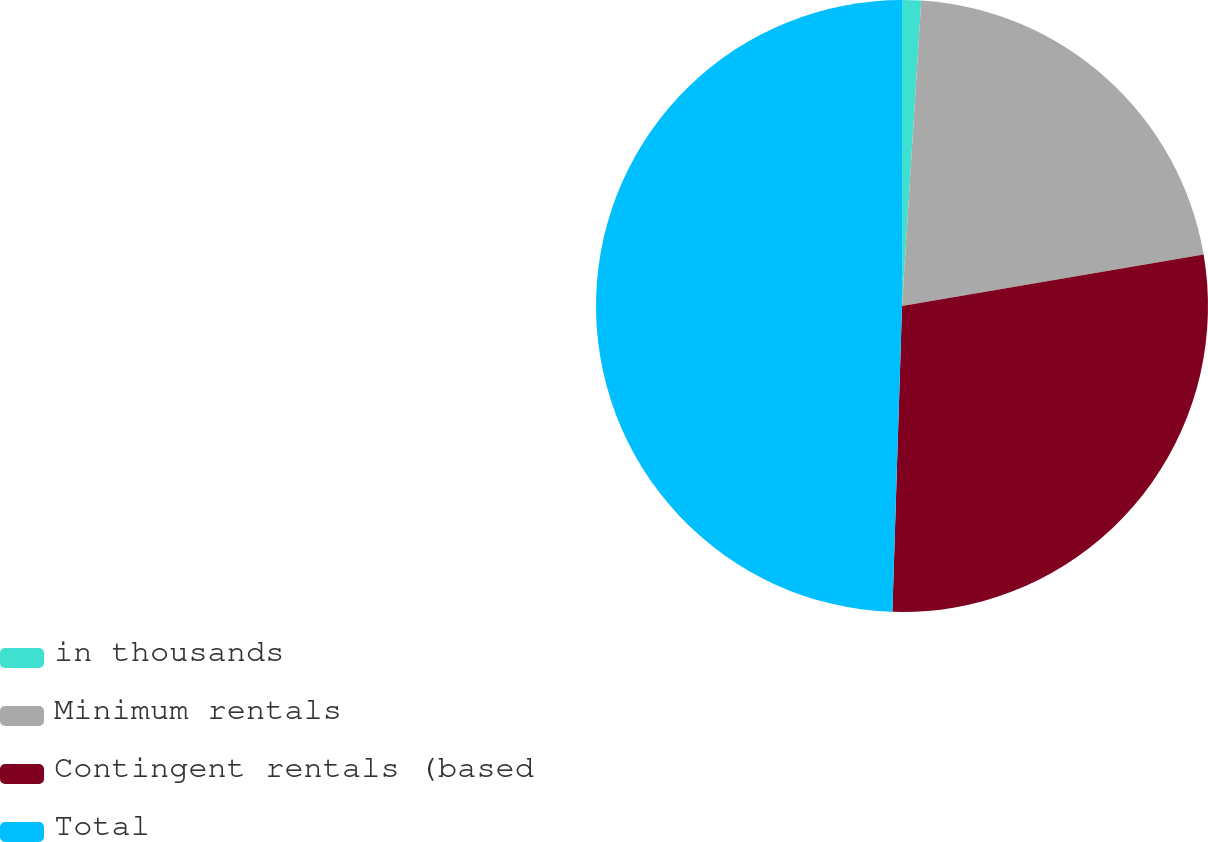Convert chart to OTSL. <chart><loc_0><loc_0><loc_500><loc_500><pie_chart><fcel>in thousands<fcel>Minimum rentals<fcel>Contingent rentals (based<fcel>Total<nl><fcel>1.0%<fcel>21.31%<fcel>28.19%<fcel>49.5%<nl></chart> 